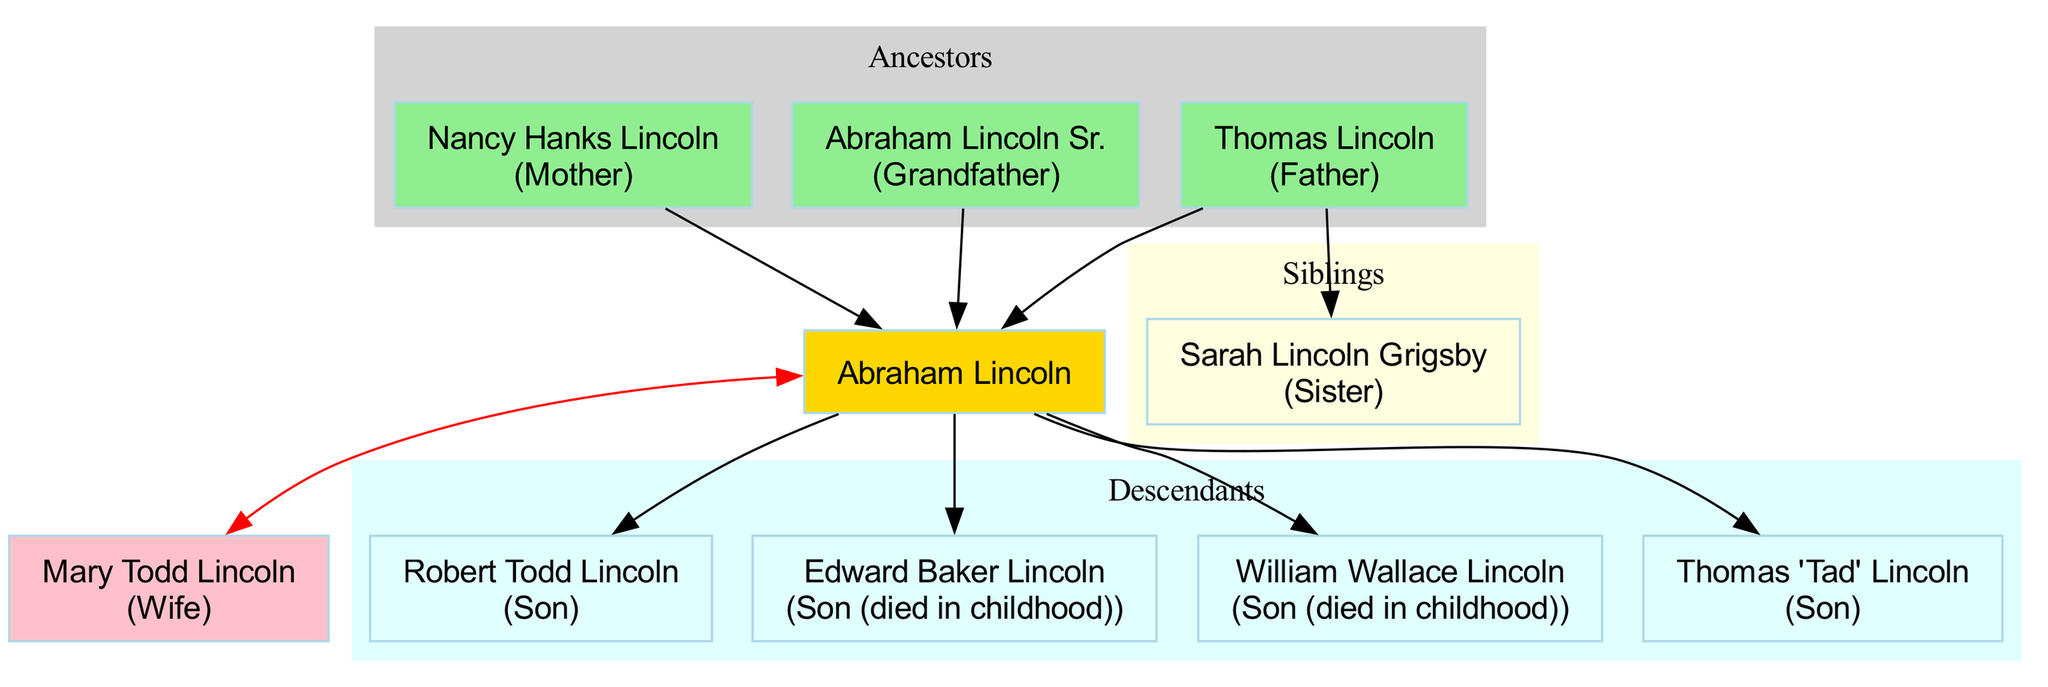What is the name of Abraham Lincoln's father? The diagram shows that Abraham Lincoln's father is Thomas Lincoln, as indicated under the ancestors section.
Answer: Thomas Lincoln How many siblings did Abraham Lincoln have? The diagram lists only one sibling, Sarah Lincoln Grigsby, which is the total count of siblings Abraham Lincoln had.
Answer: 1 Who is Abraham Lincoln's spouse? The diagram shows that Abraham Lincoln's spouse is Mary Todd Lincoln, clearly indicated in the family tree.
Answer: Mary Todd Lincoln What relationship did Edward Baker Lincoln have to Abraham Lincoln? According to the diagram, Edward Baker Lincoln is listed as a son who died in childhood, which establishes his relationship to Abraham Lincoln.
Answer: Son (died in childhood) Name one of Abraham Lincoln's sons who died in childhood. The diagram specifies that both Edward Baker Lincoln and William Wallace Lincoln are sons of Abraham Lincoln who died in childhood. The question asks for just one name, so either is a correct answer.
Answer: Edward Baker Lincoln How many descendants are shown in the diagram? The descendants section lists four individuals: Robert Todd Lincoln, Edward Baker Lincoln, William Wallace Lincoln, and Thomas 'Tad' Lincoln. To find the answer, count each of these descendants.
Answer: 4 What is the relationship between Abraham Lincoln and Thomas 'Tad' Lincoln? The diagram identifies Thomas 'Tad' Lincoln as a son of Abraham Lincoln, establishing their familial relationship directly.
Answer: Son Who is the grandfather of Abraham Lincoln? The diagram indicates that Abraham Lincoln Sr. is listed as the grandfather of Abraham Lincoln under the ancestors section, which directly answers the question.
Answer: Abraham Lincoln Sr Which section of the diagram is colored light yellow? The diagram specifically colors the siblings section light yellow, as noted in the formatting of the tree.
Answer: Siblings 